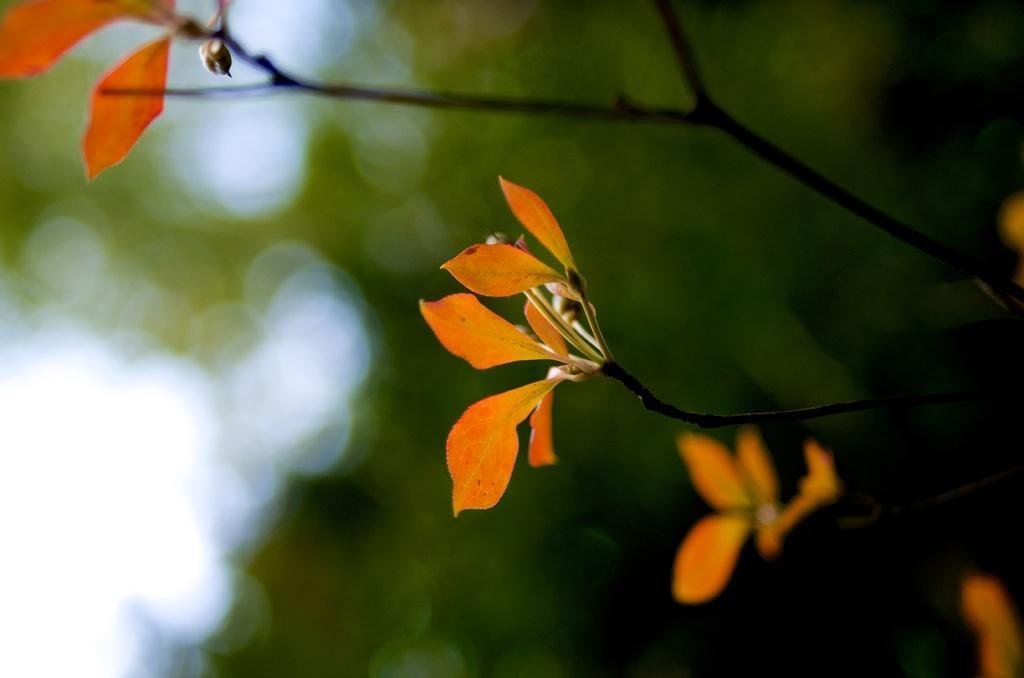Can you describe this image briefly? In this image I can see many leaves and i can see the background is blurred. 